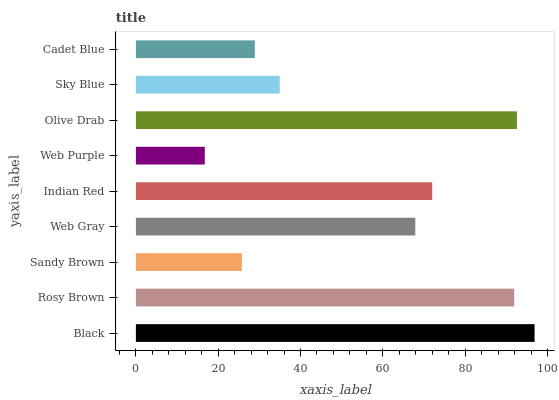Is Web Purple the minimum?
Answer yes or no. Yes. Is Black the maximum?
Answer yes or no. Yes. Is Rosy Brown the minimum?
Answer yes or no. No. Is Rosy Brown the maximum?
Answer yes or no. No. Is Black greater than Rosy Brown?
Answer yes or no. Yes. Is Rosy Brown less than Black?
Answer yes or no. Yes. Is Rosy Brown greater than Black?
Answer yes or no. No. Is Black less than Rosy Brown?
Answer yes or no. No. Is Web Gray the high median?
Answer yes or no. Yes. Is Web Gray the low median?
Answer yes or no. Yes. Is Rosy Brown the high median?
Answer yes or no. No. Is Sandy Brown the low median?
Answer yes or no. No. 